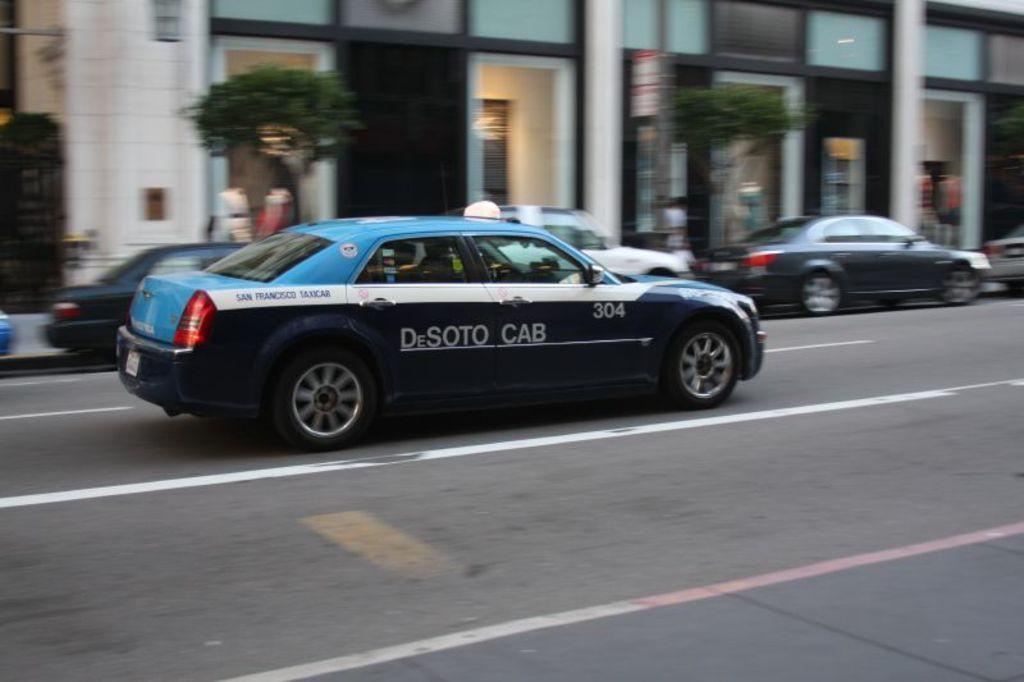What can be seen in the image related to vehicles? There are cars parked in the image, and there is a car moving on the road in the image. What else is visible in the image besides vehicles? There are buildings and trees visible in the image. What type of joke is being told by the parent in the image? There is no parent or joke present in the image. What kind of music can be heard playing in the background of the image? There is no music or sound present in the image. 